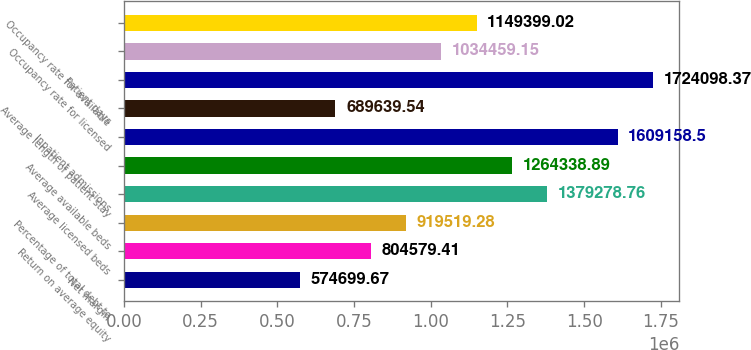<chart> <loc_0><loc_0><loc_500><loc_500><bar_chart><fcel>Net margin<fcel>Return on average equity<fcel>Percentage of total debt to<fcel>Average licensed beds<fcel>Average available beds<fcel>Inpatient admissions<fcel>Average length of patient stay<fcel>Patient days<fcel>Occupancy rate for licensed<fcel>Occupancy rate for available<nl><fcel>574700<fcel>804579<fcel>919519<fcel>1.37928e+06<fcel>1.26434e+06<fcel>1.60916e+06<fcel>689640<fcel>1.7241e+06<fcel>1.03446e+06<fcel>1.1494e+06<nl></chart> 